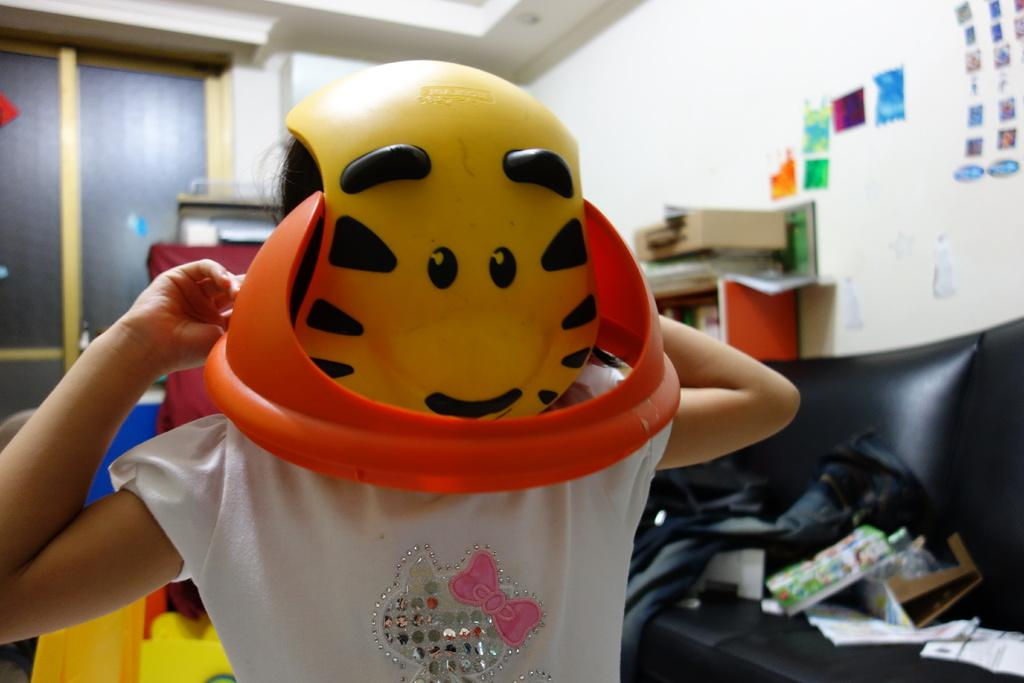What is the person in the image wearing on their face? The person in the image is wearing a mask. What can be seen in the background of the image? There are objects and bags on a sofa set, a cupboard, papers pasted on the wall, and windows in the background. What type of church is visible through the windows in the image? There is no church visible through the windows in the image; the windows show the outdoor environment. 